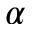<formula> <loc_0><loc_0><loc_500><loc_500>\alpha</formula> 